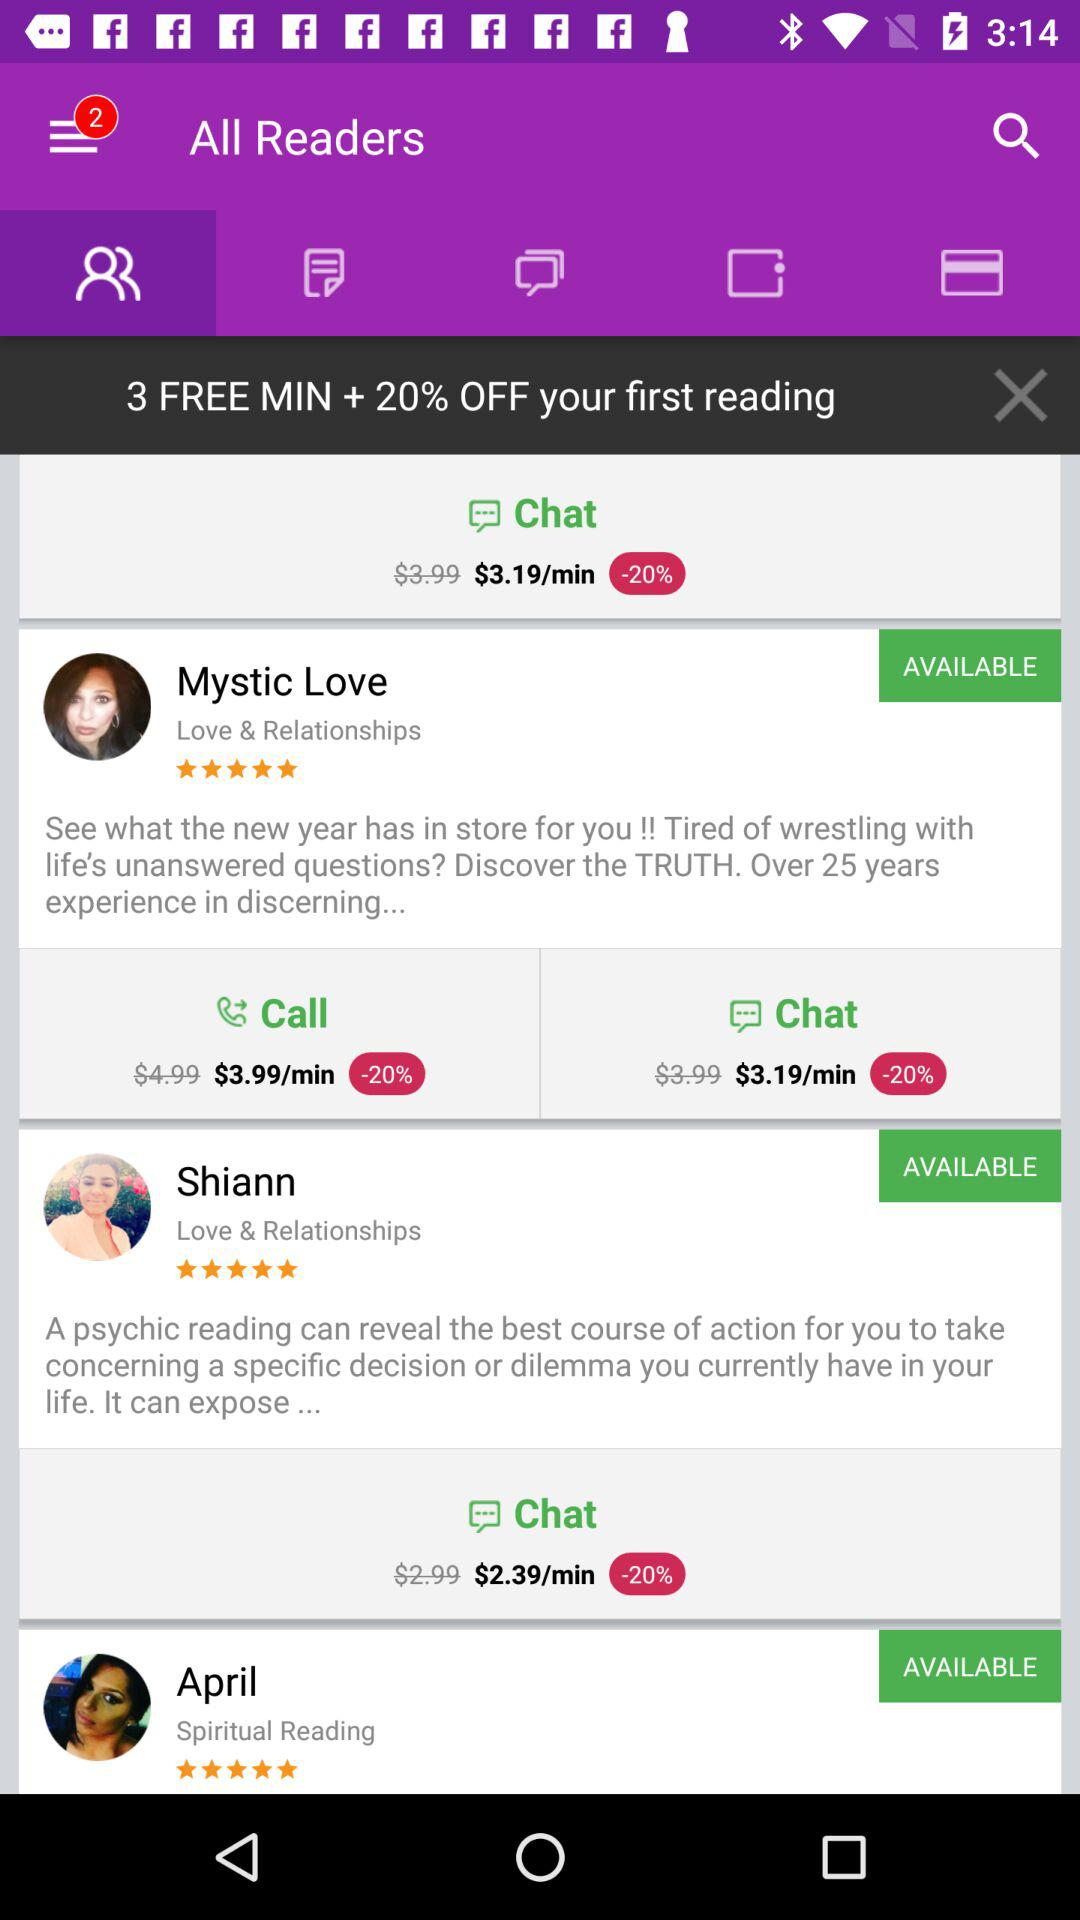How many free minutes does the user get?
Answer the question using a single word or phrase. 3 